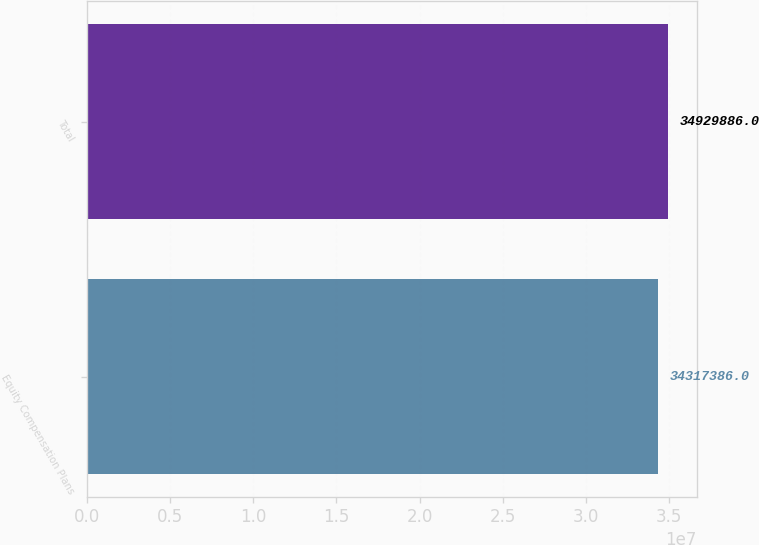<chart> <loc_0><loc_0><loc_500><loc_500><bar_chart><fcel>Equity Compensation Plans<fcel>Total<nl><fcel>3.43174e+07<fcel>3.49299e+07<nl></chart> 